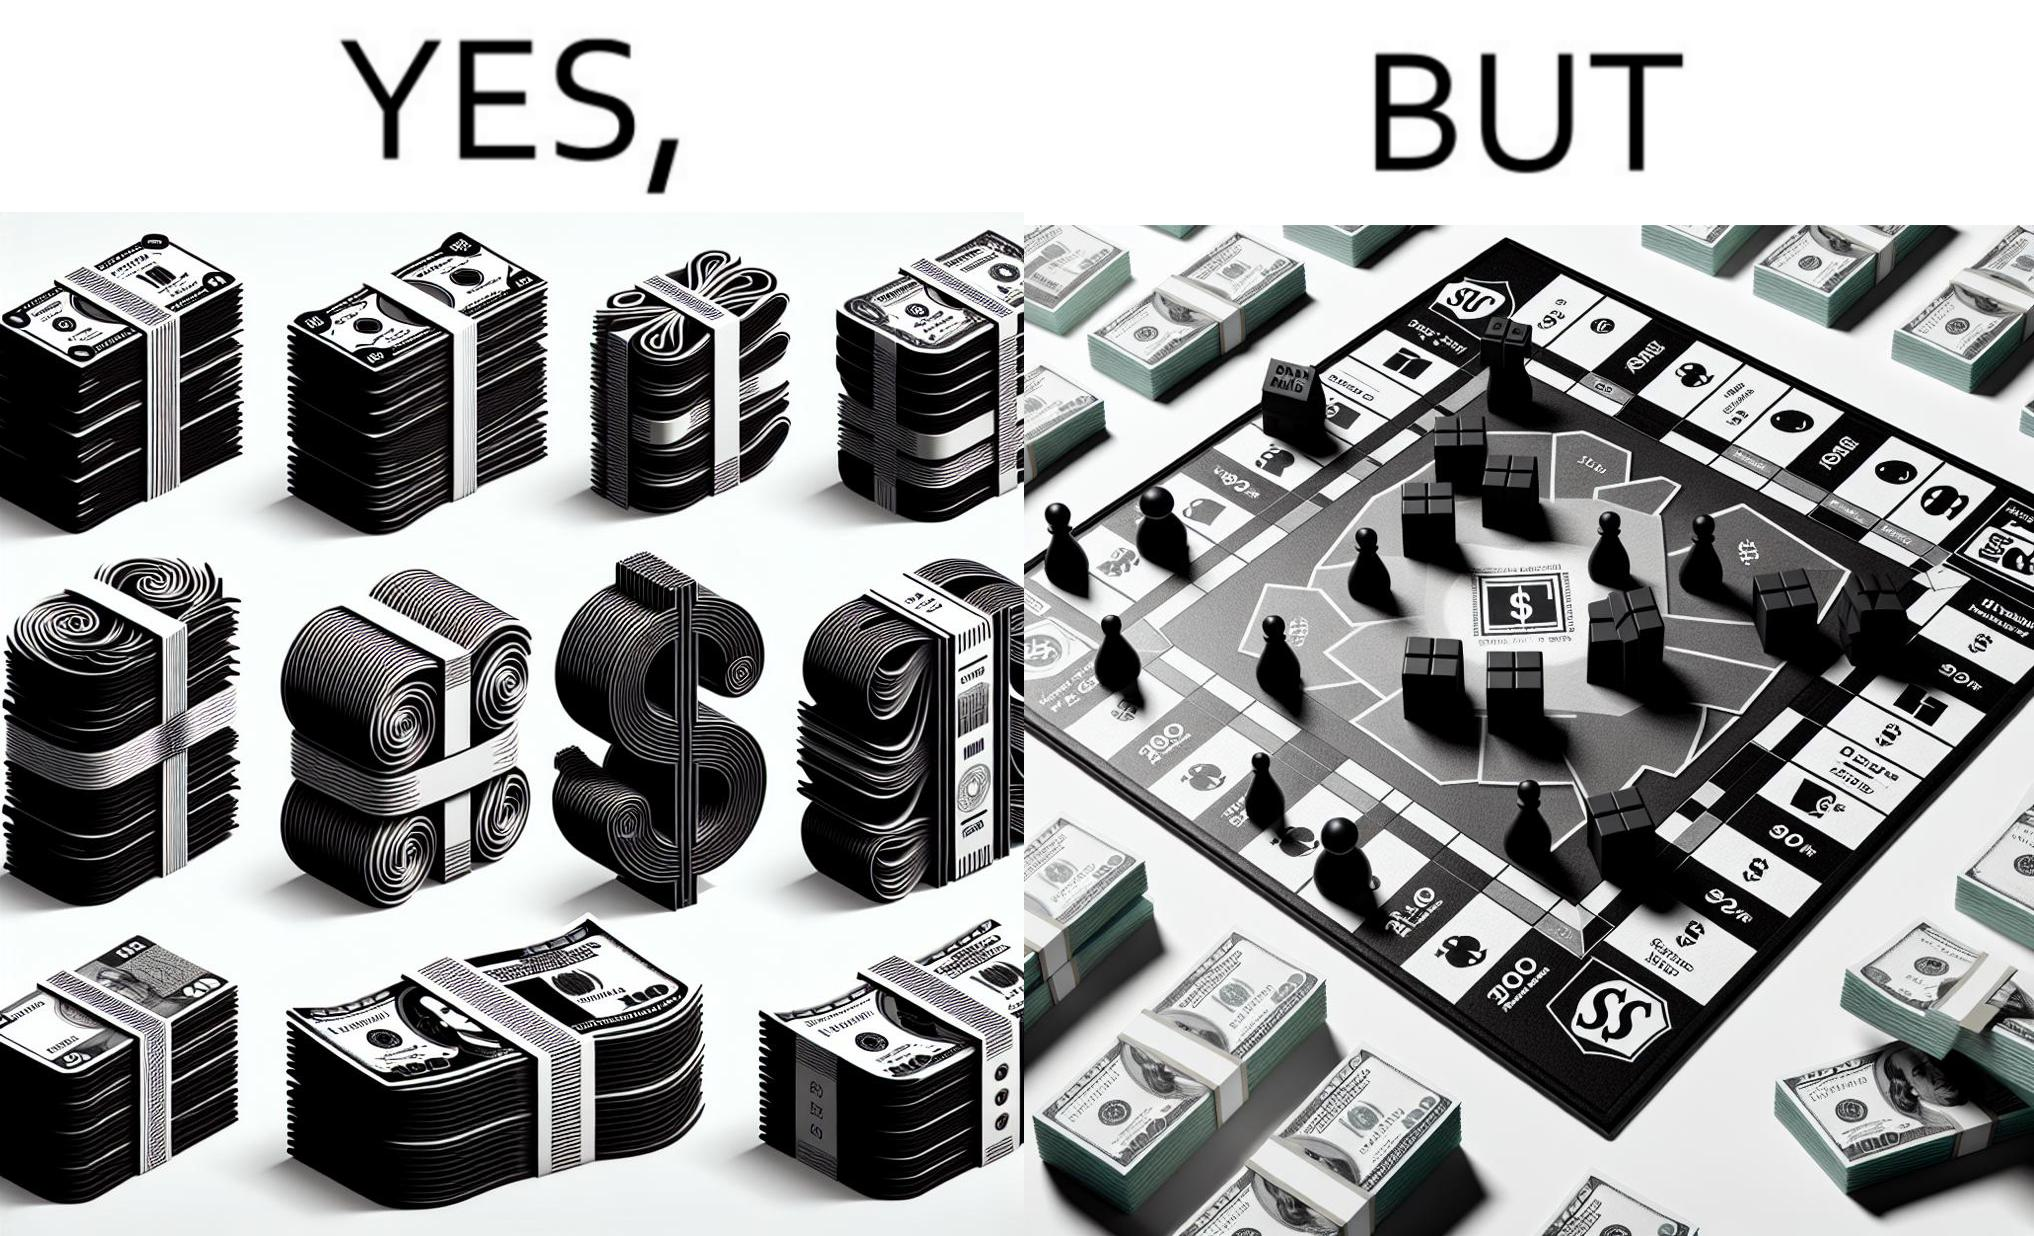Compare the left and right sides of this image. In the left part of the image: many different color currency notes' bundles In the right part of the image: a board of game monopoly with many different color currency notes' bundles 